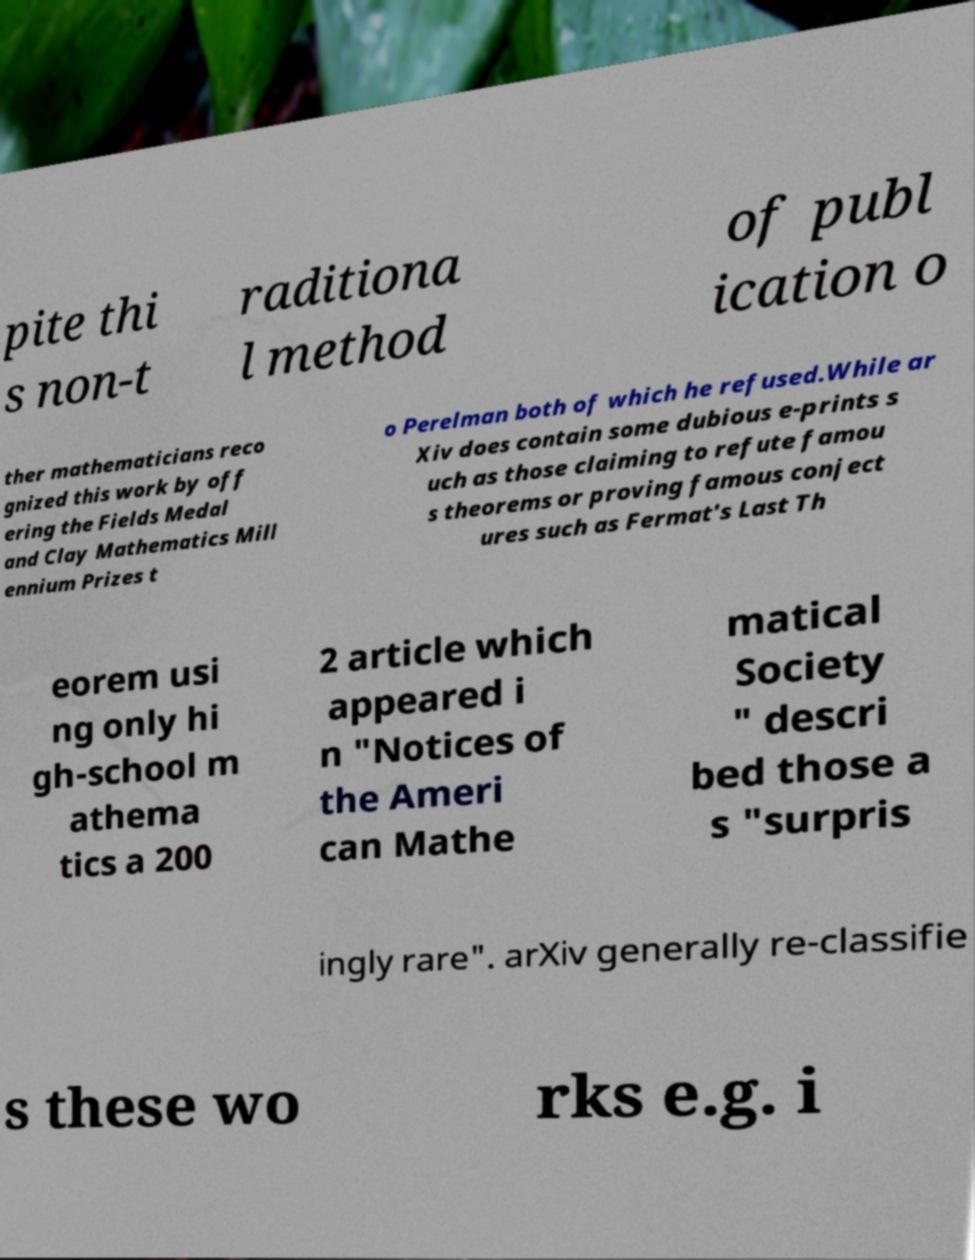Please identify and transcribe the text found in this image. pite thi s non-t raditiona l method of publ ication o ther mathematicians reco gnized this work by off ering the Fields Medal and Clay Mathematics Mill ennium Prizes t o Perelman both of which he refused.While ar Xiv does contain some dubious e-prints s uch as those claiming to refute famou s theorems or proving famous conject ures such as Fermat's Last Th eorem usi ng only hi gh-school m athema tics a 200 2 article which appeared i n "Notices of the Ameri can Mathe matical Society " descri bed those a s "surpris ingly rare". arXiv generally re-classifie s these wo rks e.g. i 